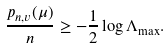Convert formula to latex. <formula><loc_0><loc_0><loc_500><loc_500>\frac { p _ { n , v } ( \mu ) } { n } \geq - \frac { 1 } { 2 } \log \Lambda _ { \max } .</formula> 